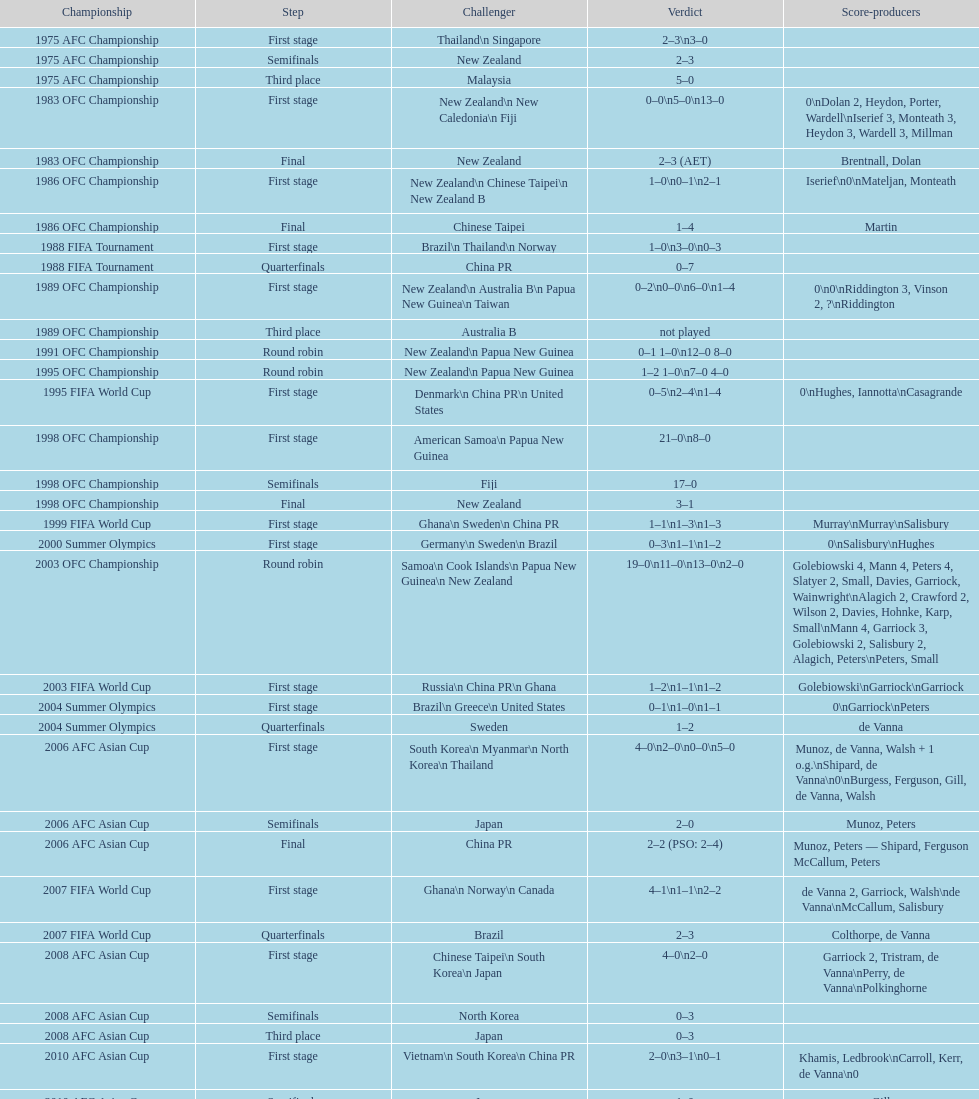Who scored better in the 1995 fifa world cup denmark or the united states? United States. 